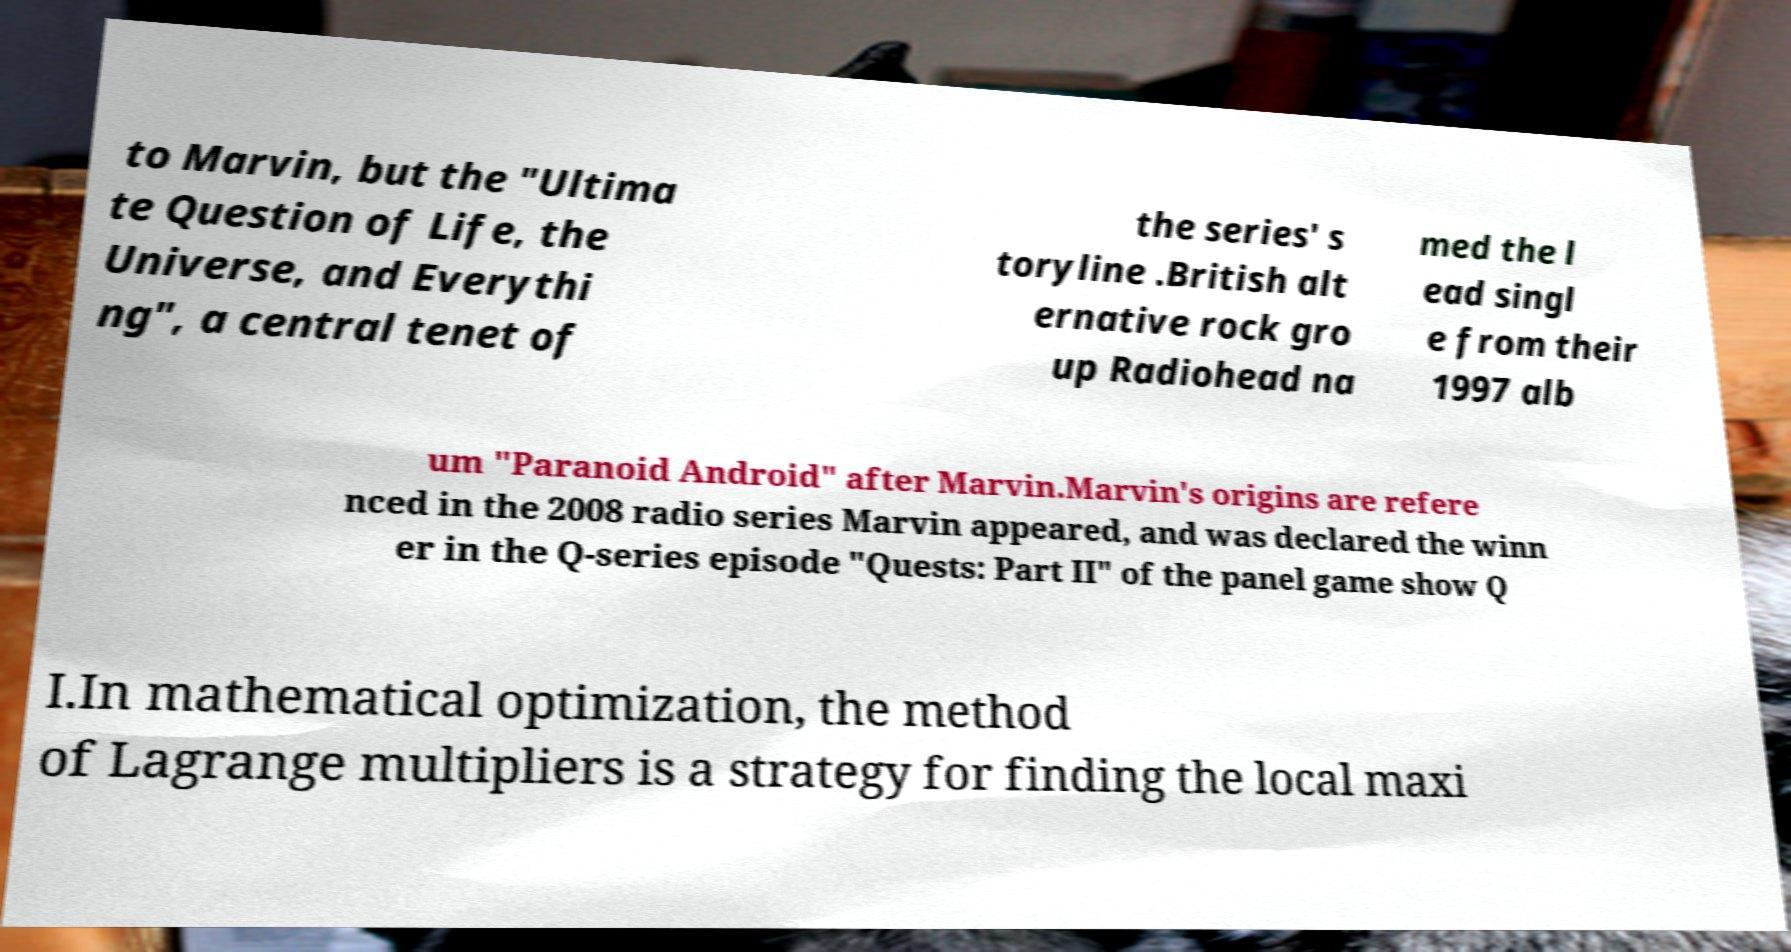Please identify and transcribe the text found in this image. to Marvin, but the "Ultima te Question of Life, the Universe, and Everythi ng", a central tenet of the series' s toryline .British alt ernative rock gro up Radiohead na med the l ead singl e from their 1997 alb um "Paranoid Android" after Marvin.Marvin's origins are refere nced in the 2008 radio series Marvin appeared, and was declared the winn er in the Q-series episode "Quests: Part II" of the panel game show Q I.In mathematical optimization, the method of Lagrange multipliers is a strategy for finding the local maxi 